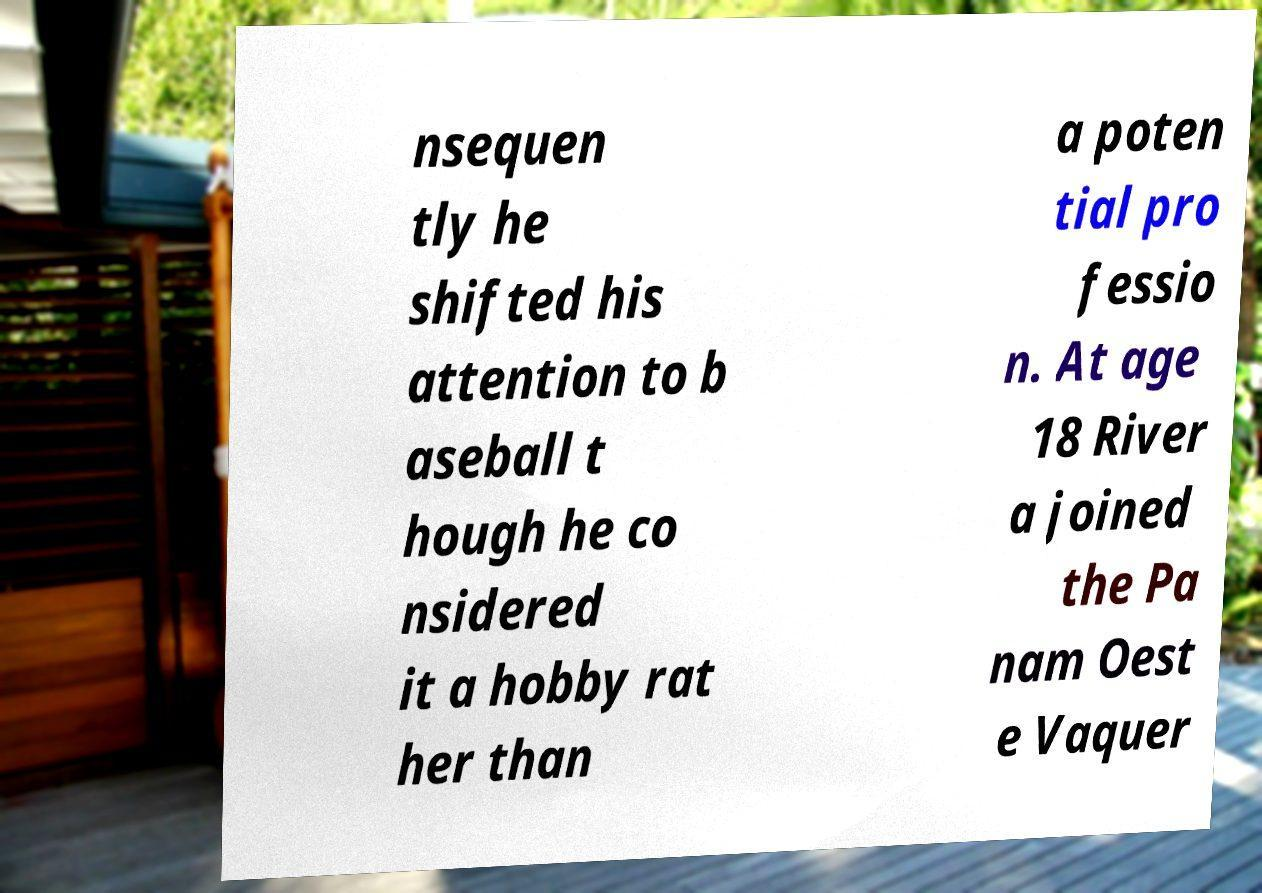Can you accurately transcribe the text from the provided image for me? nsequen tly he shifted his attention to b aseball t hough he co nsidered it a hobby rat her than a poten tial pro fessio n. At age 18 River a joined the Pa nam Oest e Vaquer 